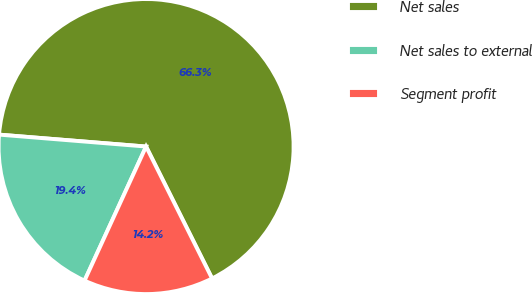Convert chart to OTSL. <chart><loc_0><loc_0><loc_500><loc_500><pie_chart><fcel>Net sales<fcel>Net sales to external<fcel>Segment profit<nl><fcel>66.33%<fcel>19.44%<fcel>14.23%<nl></chart> 